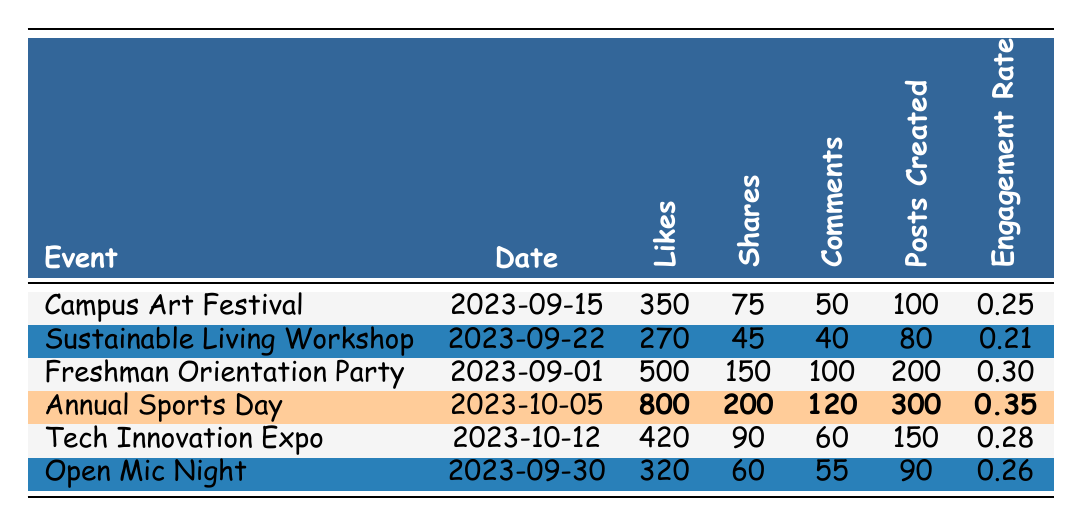What is the date of the Annual Sports Day? The table lists the event "Annual Sports Day" which is in the second column of the row. The date in that column is "2023-10-05".
Answer: 2023-10-05 Which event had the highest number of likes? The table shows the likes for each event. The highest value is 800 for "Annual Sports Day".
Answer: Annual Sports Day How many shares were received for the Freshman Orientation Party? The shares for "Freshman Orientation Party" are in its respective row in the shares column, which is 150.
Answer: 150 What is the engagement rate of the Sustainable Living Workshop? The engagement rate for "Sustainable Living Workshop" is stated in the last column of its row, which is 0.21.
Answer: 0.21 What is the total number of comments for all the events combined? The total number of comments is calculated by summing the individual comments: 50 + 40 + 100 + 120 + 60 + 55 = 425.
Answer: 425 Which event had the lowest engagement rate? The engagement rates are listed in the last column. The lowest value is 0.21, corresponding to the "Sustainable Living Workshop".
Answer: Sustainable Living Workshop What is the difference in likes between the Annual Sports Day and the Tech Innovation Expo? The likes for "Annual Sports Day" are 800 and for "Tech Innovation Expo" are 420. The difference is 800 - 420 = 380.
Answer: 380 What is the average engagement rate across all events? The engagement rates are 0.25, 0.21, 0.30, 0.35, 0.28, and 0.26. To find the average, sum these values to get 1.95, then divide by 6 (the number of events): 1.95 / 6 = 0.325.
Answer: 0.325 Did the Open Mic Night receive more comments than the Sustainable Living Workshop? The comments for "Open Mic Night" are 55, and for "Sustainable Living Workshop" are 40. Since 55 is greater than 40, the answer is yes.
Answer: Yes Which event had the most posts created? The column for posts created shows that "Annual Sports Day" has the highest at 300.
Answer: Annual Sports Day 